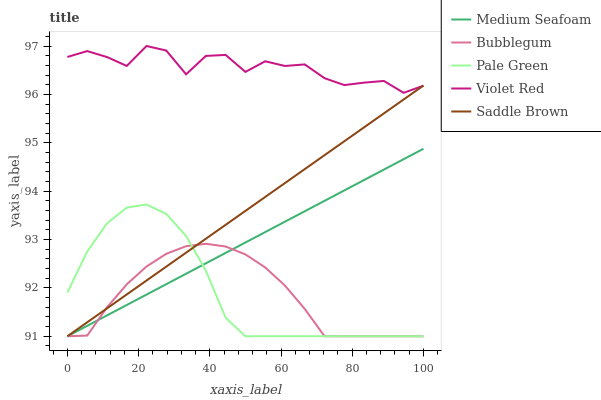Does Bubblegum have the minimum area under the curve?
Answer yes or no. Yes. Does Violet Red have the maximum area under the curve?
Answer yes or no. Yes. Does Pale Green have the minimum area under the curve?
Answer yes or no. No. Does Pale Green have the maximum area under the curve?
Answer yes or no. No. Is Saddle Brown the smoothest?
Answer yes or no. Yes. Is Violet Red the roughest?
Answer yes or no. Yes. Is Pale Green the smoothest?
Answer yes or no. No. Is Pale Green the roughest?
Answer yes or no. No. Does Pale Green have the lowest value?
Answer yes or no. Yes. Does Violet Red have the highest value?
Answer yes or no. Yes. Does Pale Green have the highest value?
Answer yes or no. No. Is Bubblegum less than Violet Red?
Answer yes or no. Yes. Is Violet Red greater than Medium Seafoam?
Answer yes or no. Yes. Does Saddle Brown intersect Bubblegum?
Answer yes or no. Yes. Is Saddle Brown less than Bubblegum?
Answer yes or no. No. Is Saddle Brown greater than Bubblegum?
Answer yes or no. No. Does Bubblegum intersect Violet Red?
Answer yes or no. No. 